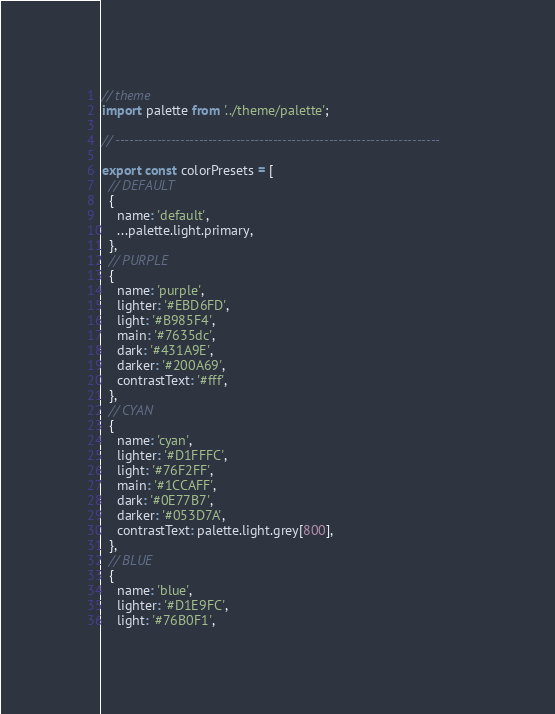Convert code to text. <code><loc_0><loc_0><loc_500><loc_500><_JavaScript_>// theme
import palette from '../theme/palette';

// ----------------------------------------------------------------------

export const colorPresets = [
  // DEFAULT
  {
    name: 'default',
    ...palette.light.primary,
  },
  // PURPLE
  {
    name: 'purple',
    lighter: '#EBD6FD',
    light: '#B985F4',
    main: '#7635dc',
    dark: '#431A9E',
    darker: '#200A69',
    contrastText: '#fff',
  },
  // CYAN
  {
    name: 'cyan',
    lighter: '#D1FFFC',
    light: '#76F2FF',
    main: '#1CCAFF',
    dark: '#0E77B7',
    darker: '#053D7A',
    contrastText: palette.light.grey[800],
  },
  // BLUE
  {
    name: 'blue',
    lighter: '#D1E9FC',
    light: '#76B0F1',</code> 